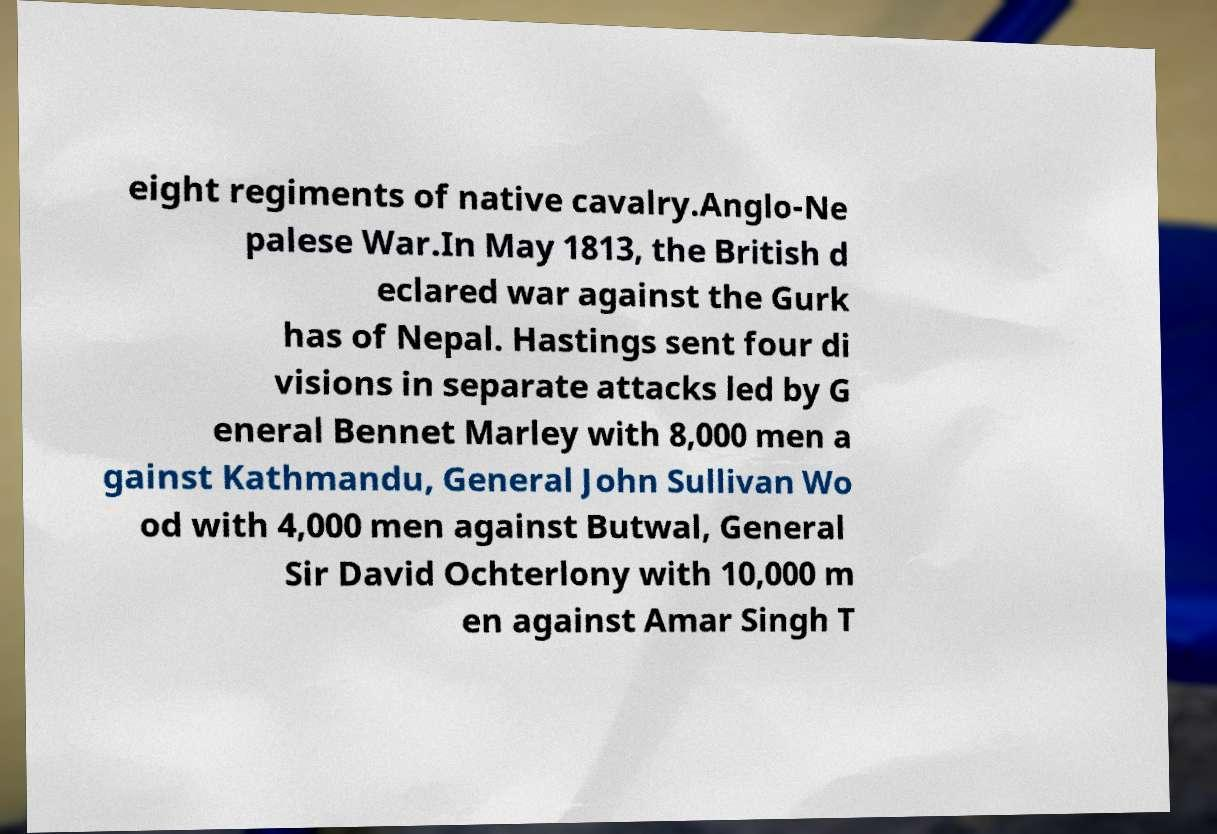Could you extract and type out the text from this image? eight regiments of native cavalry.Anglo-Ne palese War.In May 1813, the British d eclared war against the Gurk has of Nepal. Hastings sent four di visions in separate attacks led by G eneral Bennet Marley with 8,000 men a gainst Kathmandu, General John Sullivan Wo od with 4,000 men against Butwal, General Sir David Ochterlony with 10,000 m en against Amar Singh T 